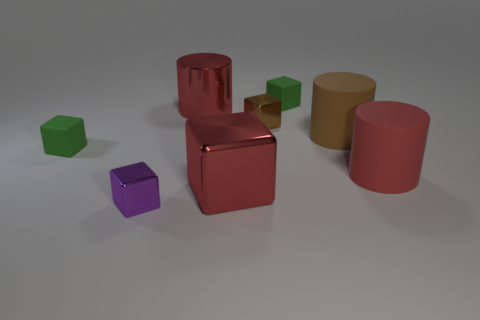Subtract all purple blocks. How many blocks are left? 4 Subtract all gray cylinders. How many green cubes are left? 2 Add 1 red metal objects. How many objects exist? 9 Subtract all cubes. How many objects are left? 3 Subtract all brown blocks. How many blocks are left? 4 Subtract 3 cubes. How many cubes are left? 2 Subtract 0 red balls. How many objects are left? 8 Subtract all brown cylinders. Subtract all brown cubes. How many cylinders are left? 2 Subtract all big cyan metal cubes. Subtract all brown cubes. How many objects are left? 7 Add 6 matte things. How many matte things are left? 10 